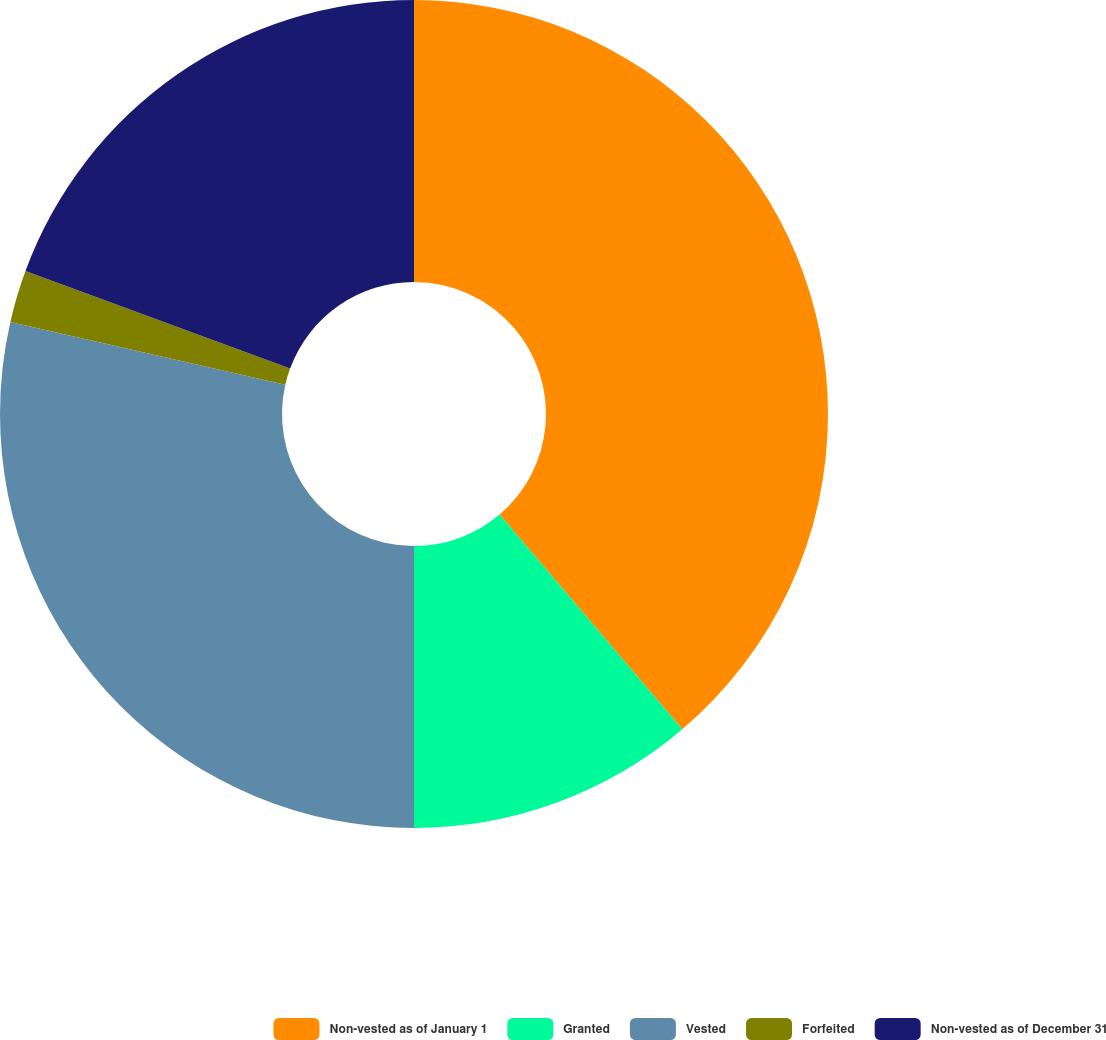<chart> <loc_0><loc_0><loc_500><loc_500><pie_chart><fcel>Non-vested as of January 1<fcel>Granted<fcel>Vested<fcel>Forfeited<fcel>Non-vested as of December 31<nl><fcel>38.78%<fcel>11.22%<fcel>28.57%<fcel>2.04%<fcel>19.39%<nl></chart> 